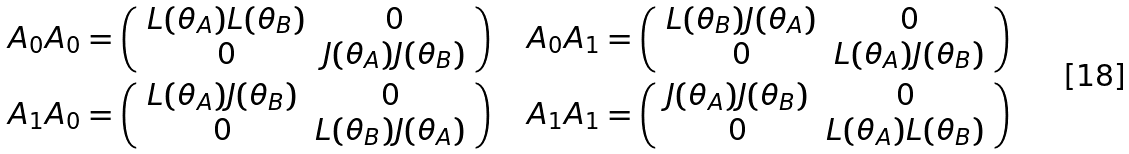Convert formula to latex. <formula><loc_0><loc_0><loc_500><loc_500>A _ { 0 } A _ { 0 } & = \left ( \begin{array} { c c } L ( \theta _ { A } ) L ( \theta _ { B } ) & 0 \\ 0 & J ( \theta _ { A } ) J ( \theta _ { B } ) \end{array} \right ) \quad A _ { 0 } A _ { 1 } = \left ( \begin{array} { c c } L ( \theta _ { B } ) J ( \theta _ { A } ) & 0 \\ 0 & L ( \theta _ { A } ) J ( \theta _ { B } ) \end{array} \right ) \\ A _ { 1 } A _ { 0 } & = \left ( \begin{array} { c c } L ( \theta _ { A } ) J ( \theta _ { B } ) & 0 \\ 0 & L ( \theta _ { B } ) J ( \theta _ { A } ) \end{array} \right ) \quad A _ { 1 } A _ { 1 } = \left ( \begin{array} { c c } J ( \theta _ { A } ) J ( \theta _ { B } ) & 0 \\ 0 & L ( \theta _ { A } ) L ( \theta _ { B } ) \end{array} \right )</formula> 